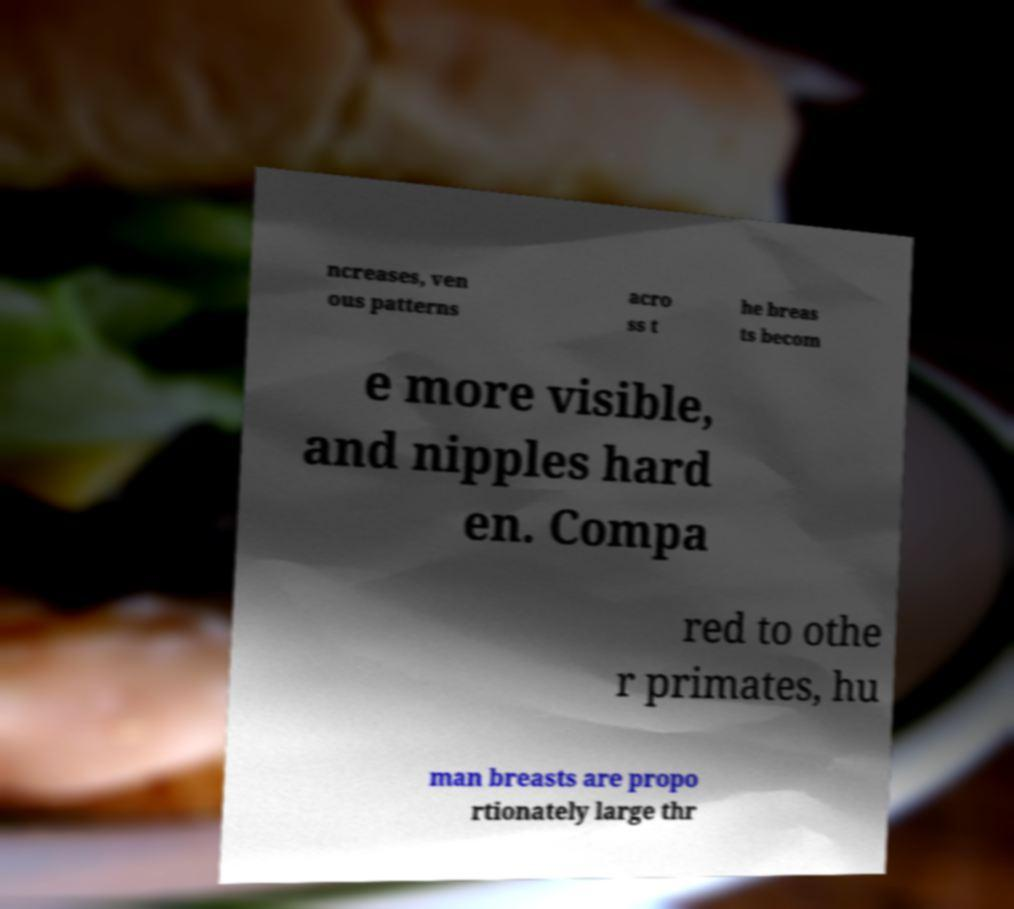Can you read and provide the text displayed in the image?This photo seems to have some interesting text. Can you extract and type it out for me? ncreases, ven ous patterns acro ss t he breas ts becom e more visible, and nipples hard en. Compa red to othe r primates, hu man breasts are propo rtionately large thr 